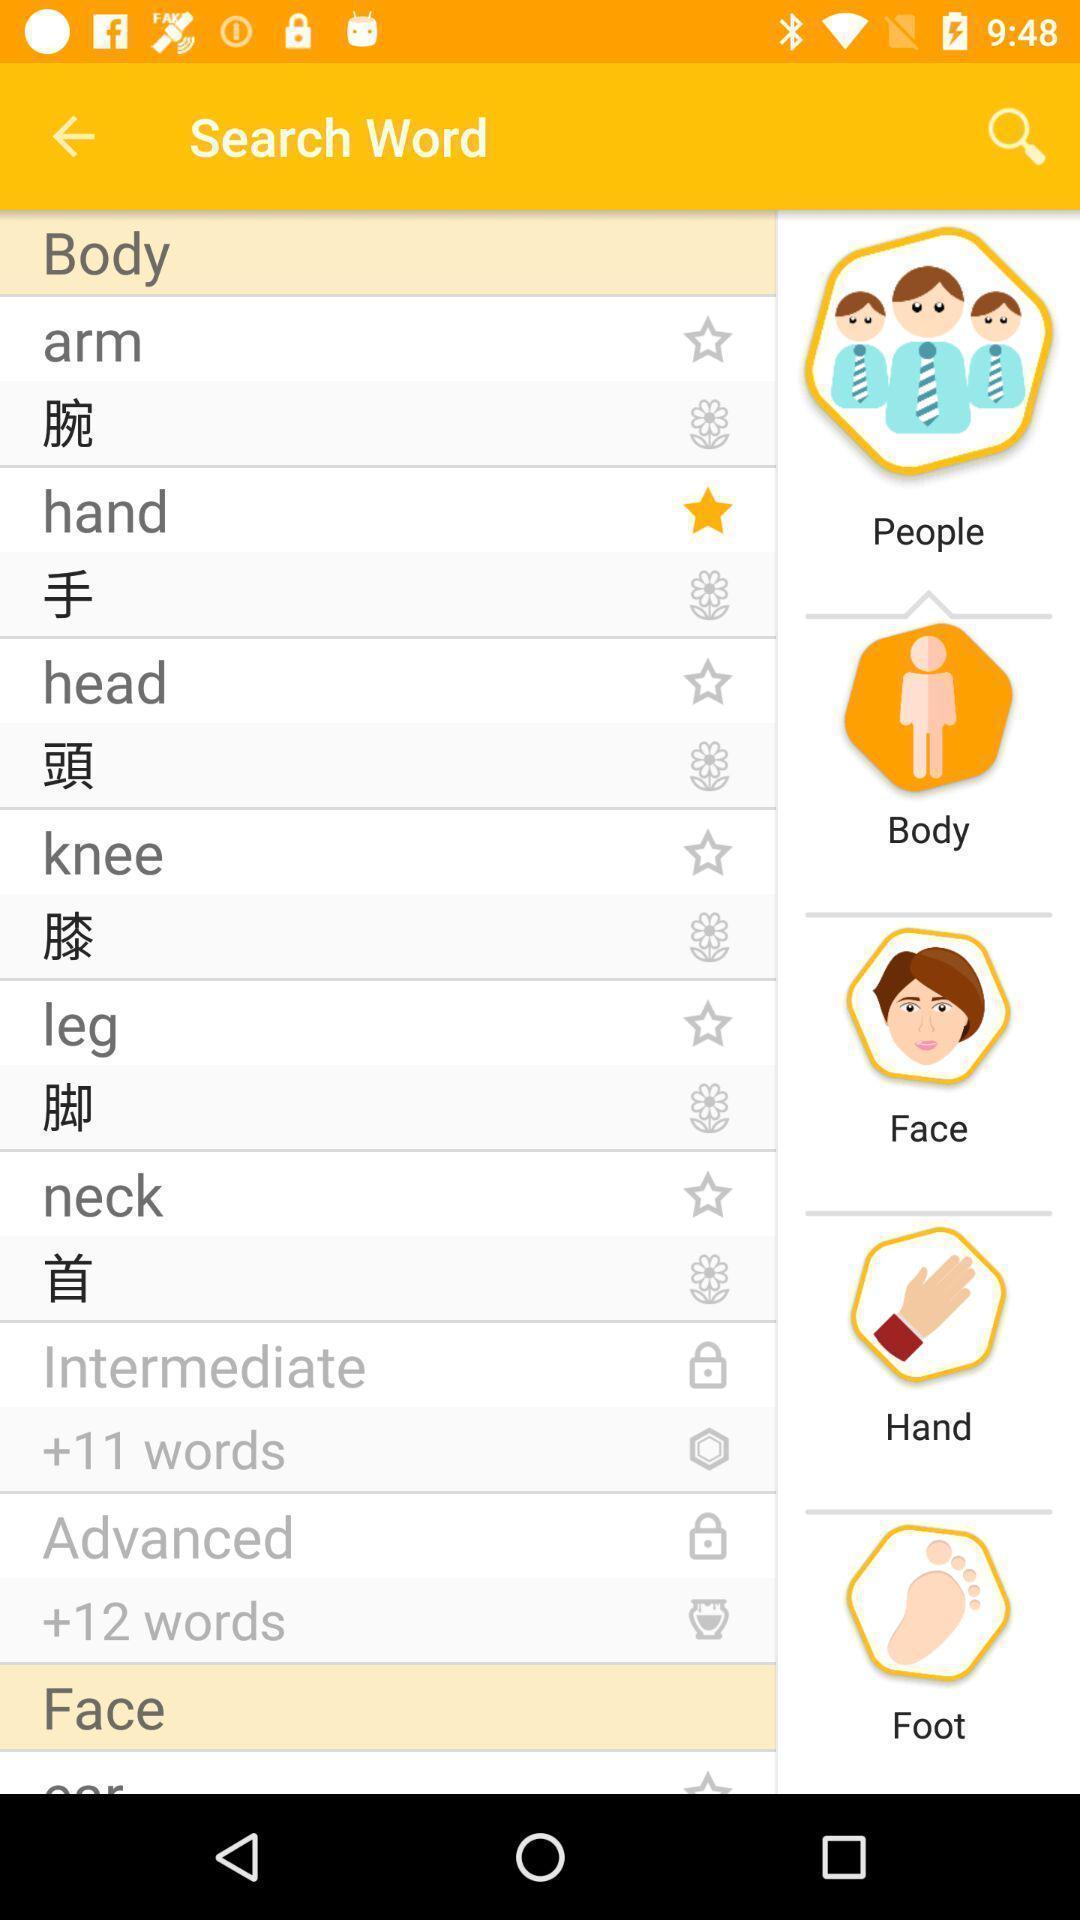Provide a description of this screenshot. Screen displaying multiple options in a language learning application. 